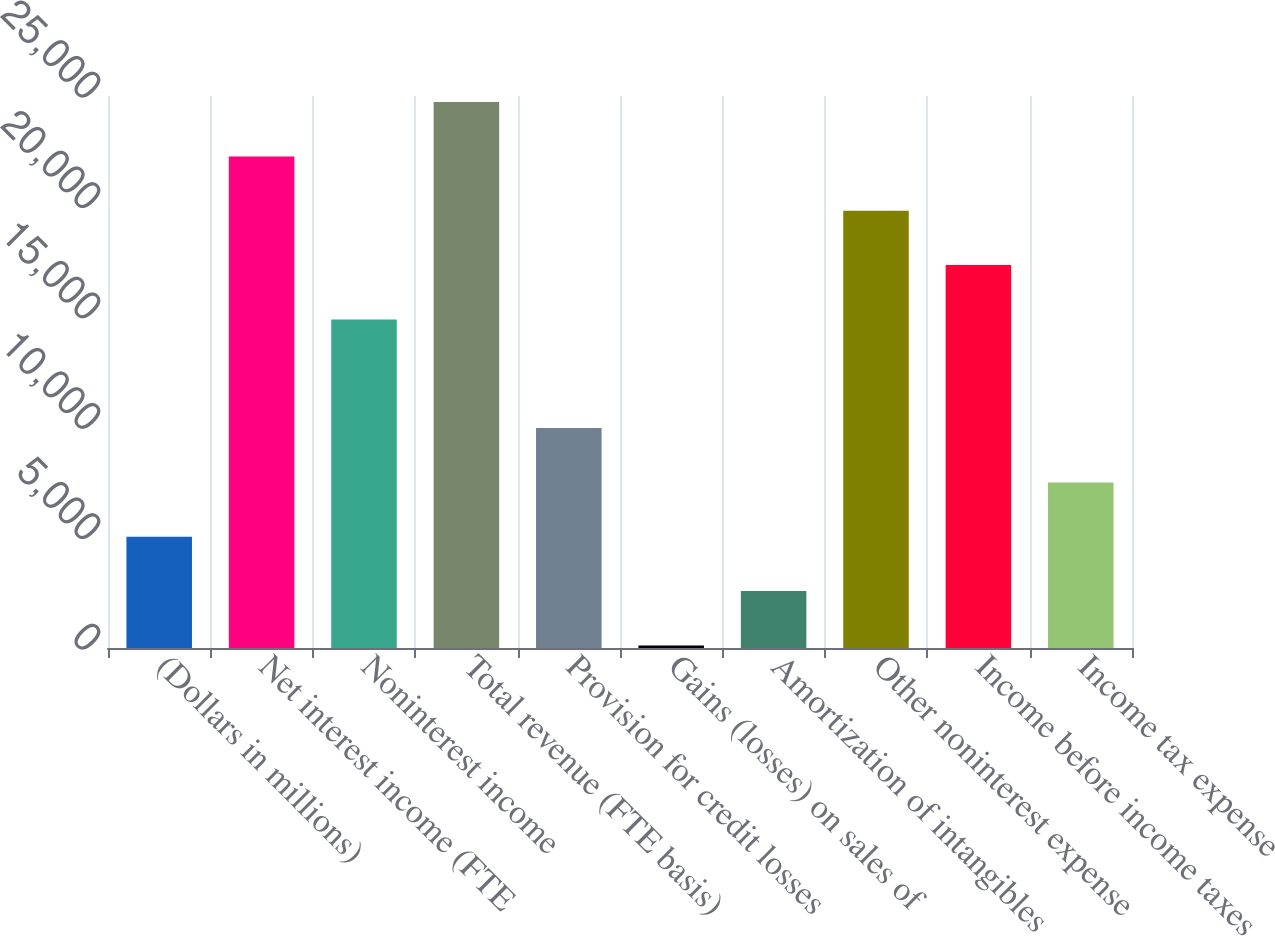<chart> <loc_0><loc_0><loc_500><loc_500><bar_chart><fcel>(Dollars in millions)<fcel>Net interest income (FTE<fcel>Noninterest income<fcel>Total revenue (FTE basis)<fcel>Provision for credit losses<fcel>Gains (losses) on sales of<fcel>Amortization of intangibles<fcel>Other noninterest expense<fcel>Income before income taxes<fcel>Income tax expense<nl><fcel>5038.6<fcel>22264.2<fcel>14881.8<fcel>24725<fcel>9960.2<fcel>117<fcel>2577.8<fcel>19803.4<fcel>17342.6<fcel>7499.4<nl></chart> 